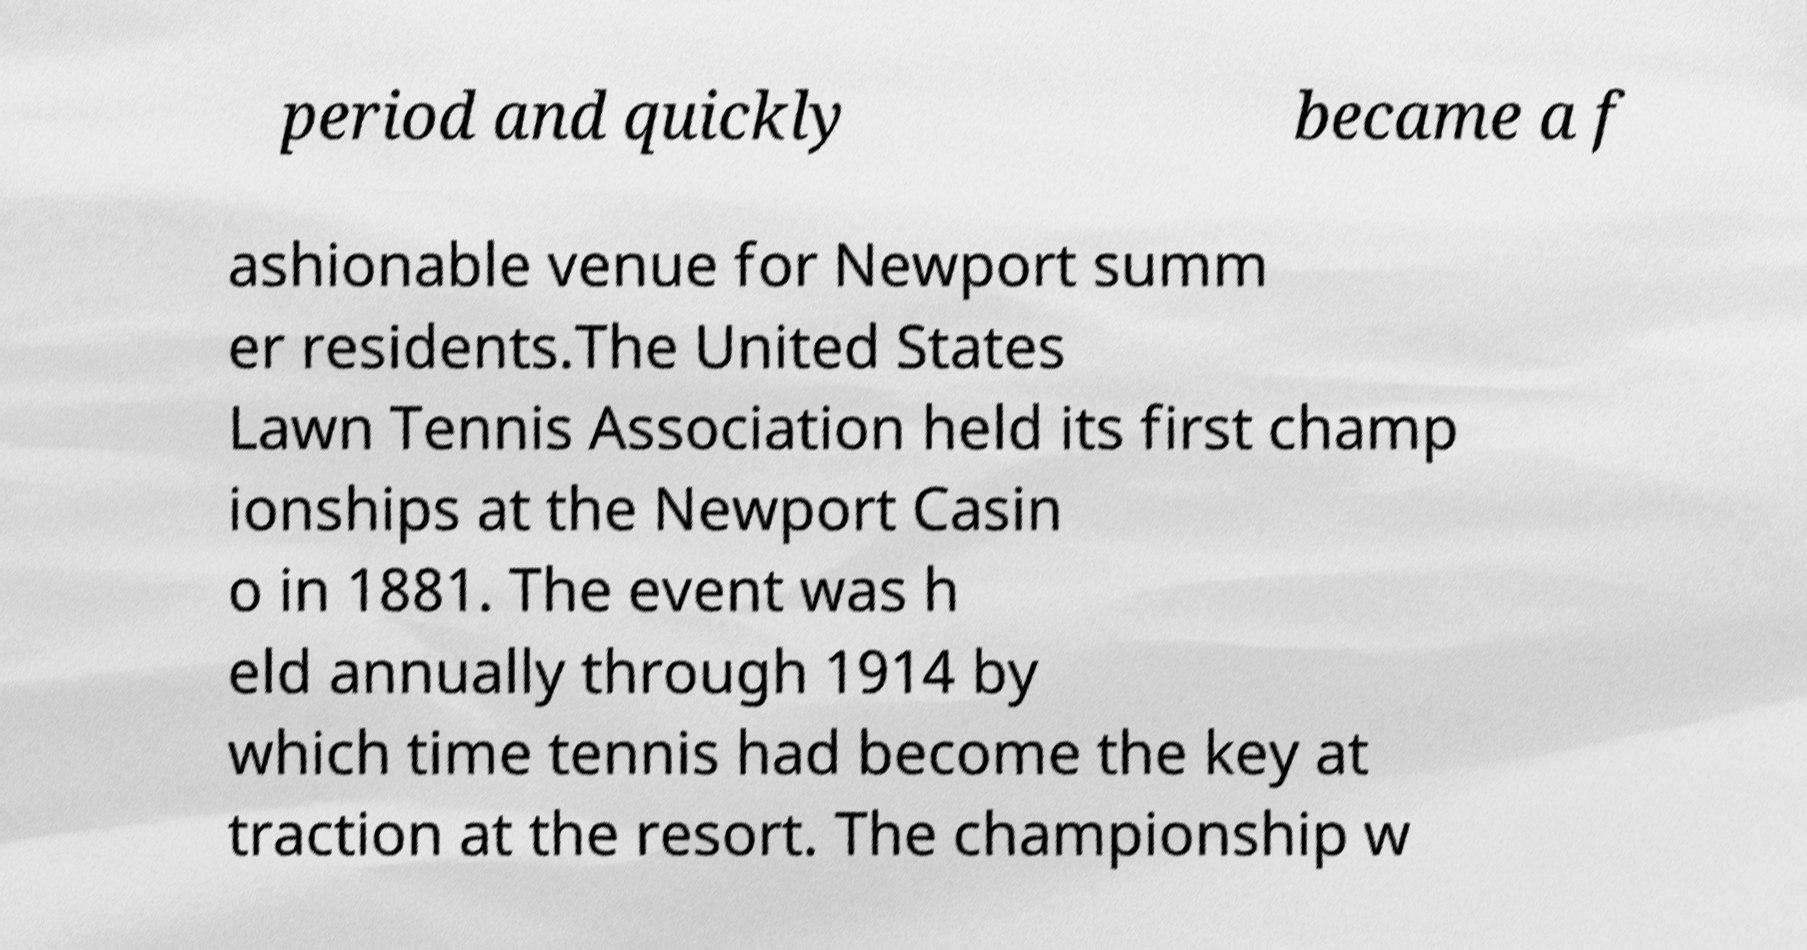Please identify and transcribe the text found in this image. period and quickly became a f ashionable venue for Newport summ er residents.The United States Lawn Tennis Association held its first champ ionships at the Newport Casin o in 1881. The event was h eld annually through 1914 by which time tennis had become the key at traction at the resort. The championship w 